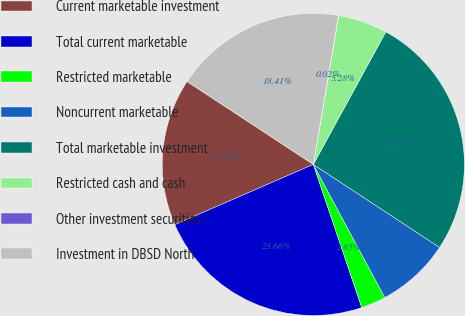Convert chart. <chart><loc_0><loc_0><loc_500><loc_500><pie_chart><fcel>Current marketable investment<fcel>Total current marketable<fcel>Restricted marketable<fcel>Noncurrent marketable<fcel>Total marketable investment<fcel>Restricted cash and cash<fcel>Other investment securities -<fcel>Investment in DBSD North<nl><fcel>15.78%<fcel>23.66%<fcel>2.65%<fcel>7.9%<fcel>26.29%<fcel>5.28%<fcel>0.02%<fcel>18.41%<nl></chart> 